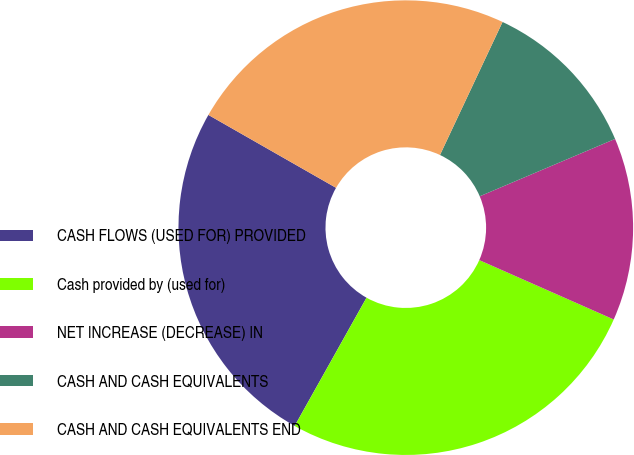<chart> <loc_0><loc_0><loc_500><loc_500><pie_chart><fcel>CASH FLOWS (USED FOR) PROVIDED<fcel>Cash provided by (used for)<fcel>NET INCREASE (DECREASE) IN<fcel>CASH AND CASH EQUIVALENTS<fcel>CASH AND CASH EQUIVALENTS END<nl><fcel>25.13%<fcel>26.51%<fcel>13.0%<fcel>11.62%<fcel>23.74%<nl></chart> 